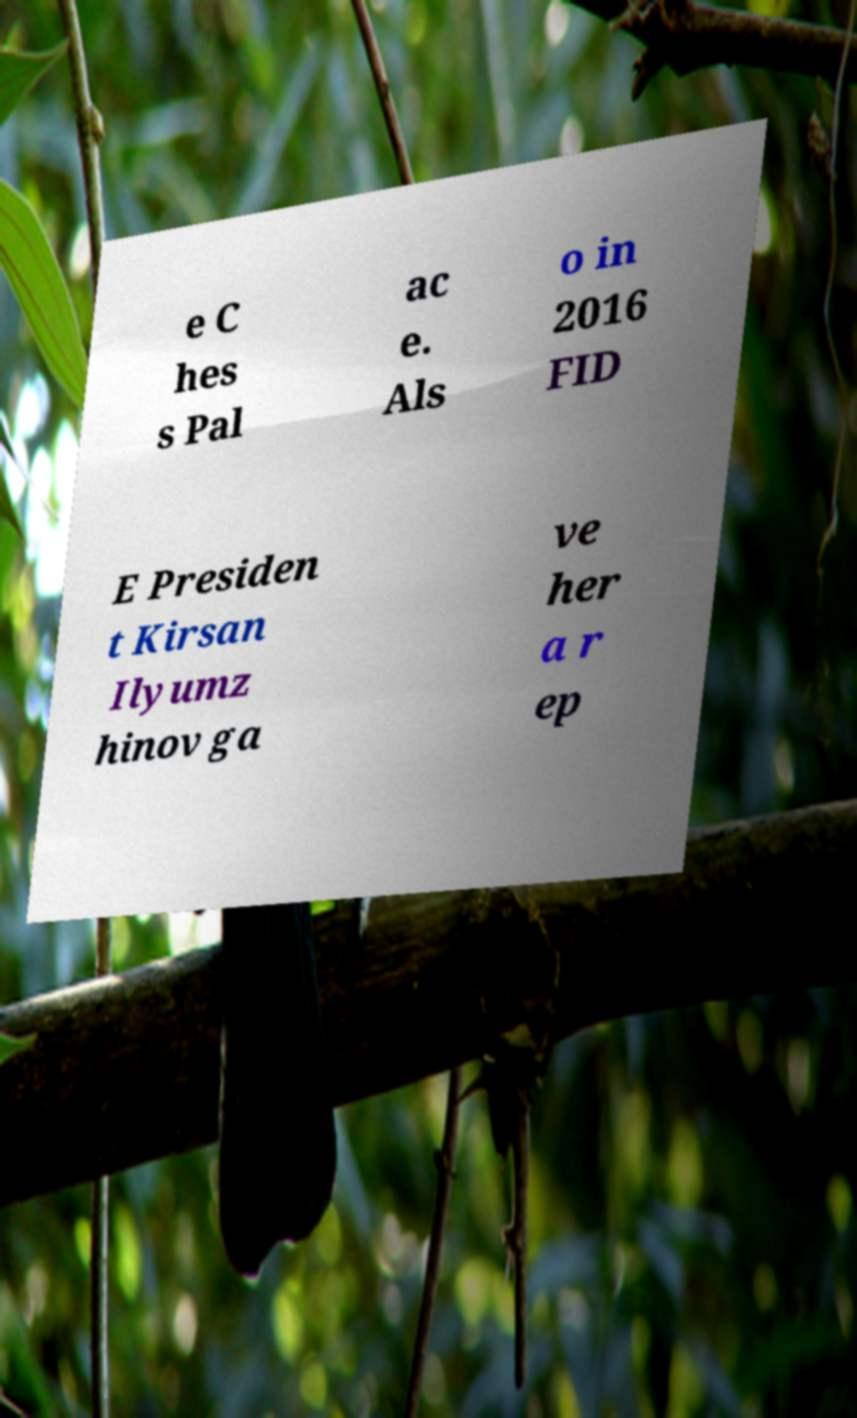Please read and relay the text visible in this image. What does it say? e C hes s Pal ac e. Als o in 2016 FID E Presiden t Kirsan Ilyumz hinov ga ve her a r ep 